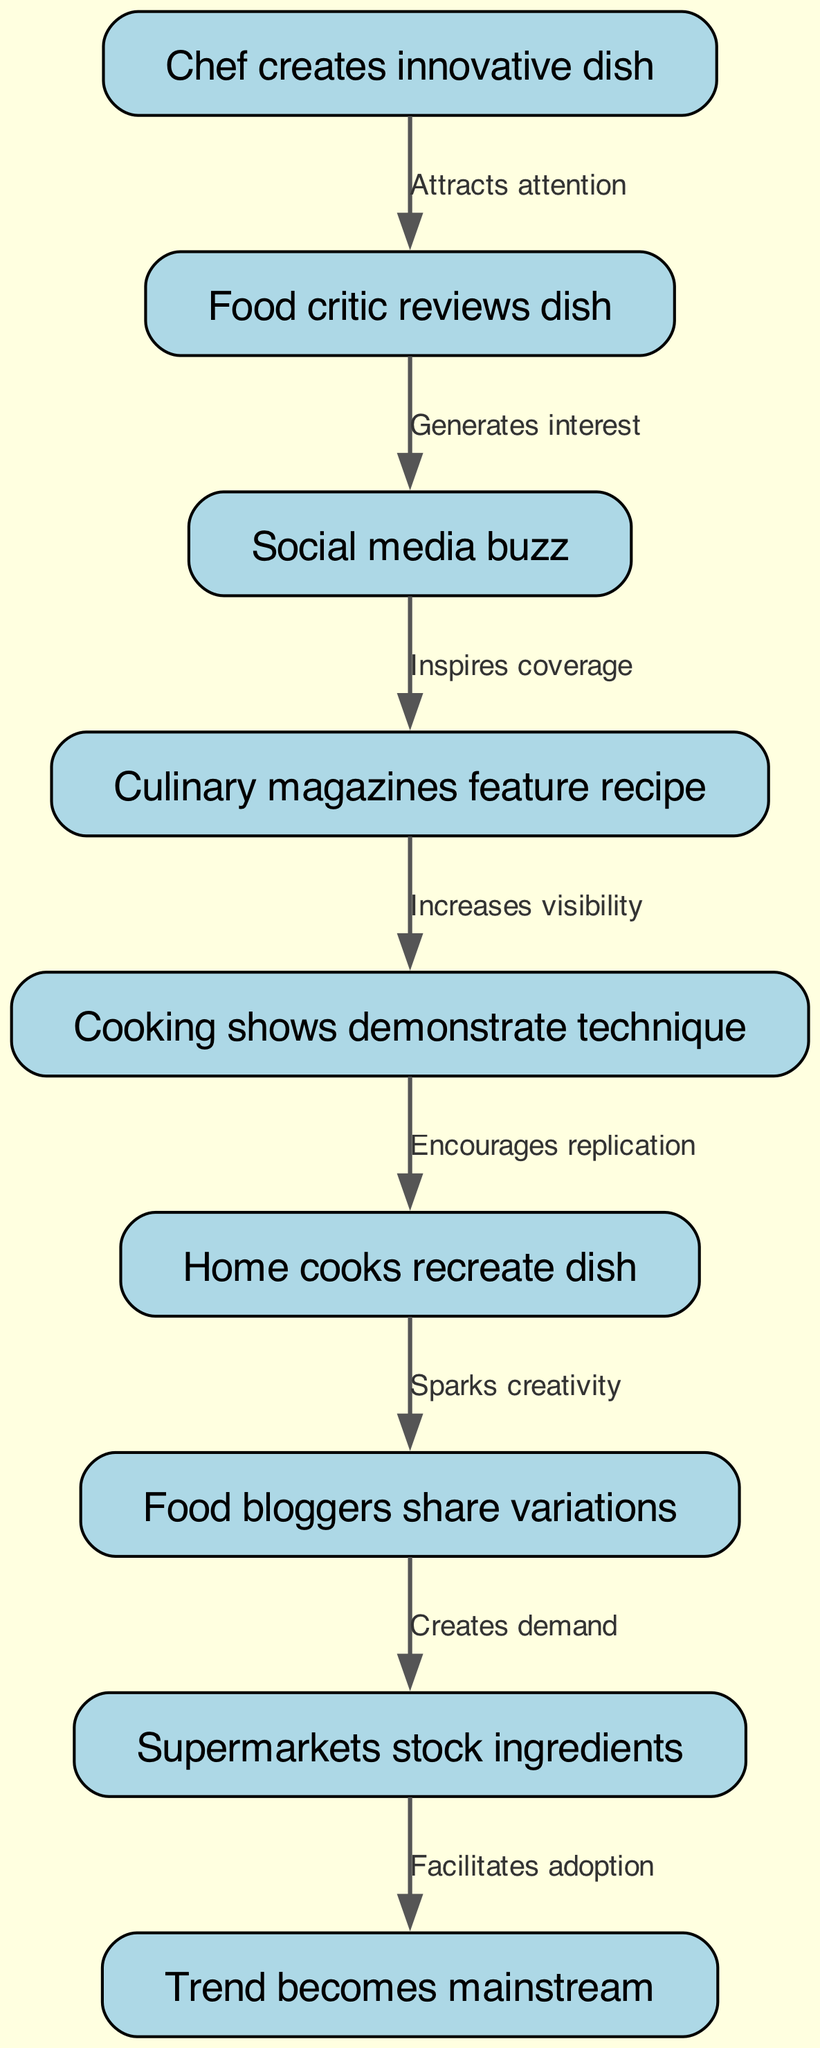What is the first step in the food trend evolution? The first step is indicated by the first node in the diagram, which states that the chef creates an innovative dish. This is the starting point of the entire process.
Answer: Chef creates innovative dish How many total nodes are in the diagram? By counting all the distinct stages represented in the diagram, there are nine nodes in total that reflect the stages of food trend evolution.
Answer: 9 Which node comes after "Food critic reviews dish"? Following the node "Food critic reviews dish," the next node according to the diagram is "Social media buzz." The directed flow shows this progression clearly.
Answer: Social media buzz What relationship exists between "Cooking shows demonstrate technique" and "Home cooks recreate dish"? The relationship between these two nodes is conveyed through the directed edge that says "Encourages replication," indicating that the demonstrations by cooking shows inspire home cooks to recreate the dishes.
Answer: Encourages replication What is the final outcome in the flow chart? The last node in the flow chart represents the final outcome of the trend evolution, which is that the trend becomes mainstream, illustrating the full circle of the trend's journey from innovation to widespread acceptance.
Answer: Trend becomes mainstream What role does "Supermarkets stock ingredients" play in the trend's adoption? This node indicates a crucial point in the flow that happens after food bloggers share variations; it represents the availability of necessary ingredients, playing a role in facilitating wider adoption of the trend. This is essential for consumers to embrace and try the new dishes.
Answer: Facilitates adoption Which node leads to the creation of demand? The node that leads to the creation of demand is "Food bloggers share variations." The sharing of different takes on a dish by bloggers generates interest and demand for the ingredients that allow for preparing those dishes.
Answer: Food bloggers share variations How does "Culinary magazines feature recipe" influence the trend? The influence of this node is indicated by the edge labeled "Increases visibility," which suggests that featuring a recipe in culinary magazines helps to raise awareness and spread knowledge about the innovative dish, thereby influencing broader adoption.
Answer: Increases visibility 